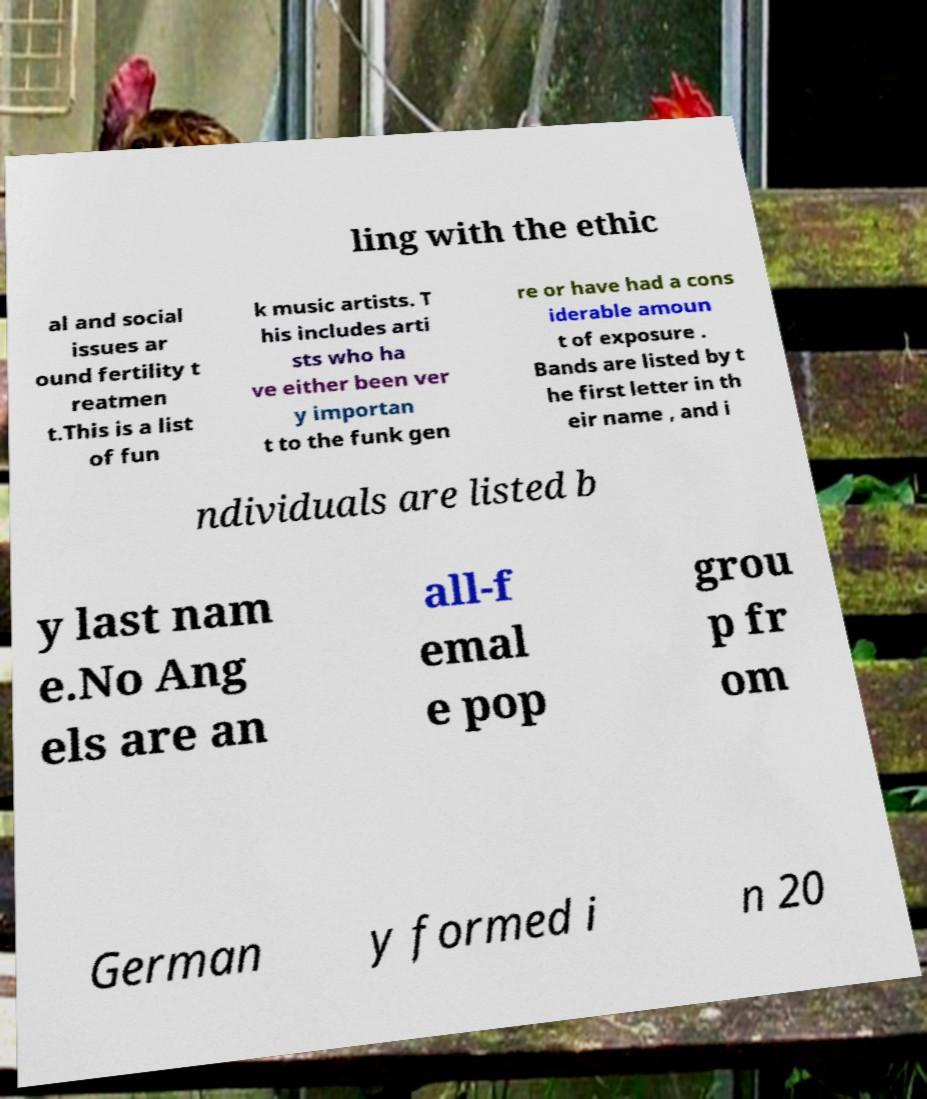There's text embedded in this image that I need extracted. Can you transcribe it verbatim? ling with the ethic al and social issues ar ound fertility t reatmen t.This is a list of fun k music artists. T his includes arti sts who ha ve either been ver y importan t to the funk gen re or have had a cons iderable amoun t of exposure . Bands are listed by t he first letter in th eir name , and i ndividuals are listed b y last nam e.No Ang els are an all-f emal e pop grou p fr om German y formed i n 20 